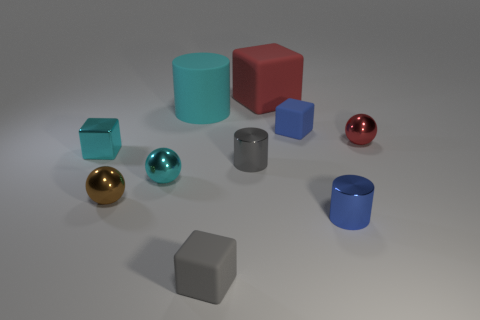What number of other objects are there of the same color as the big matte block?
Offer a terse response. 1. What is the shape of the brown shiny thing that is the same size as the gray matte cube?
Your response must be concise. Sphere. What number of large things are green metal balls or cyan metallic objects?
Give a very brief answer. 0. Is there a tiny matte block on the right side of the red object that is behind the ball that is to the right of the gray rubber block?
Ensure brevity in your answer.  Yes. Are there any metallic cylinders that have the same size as the red metal object?
Make the answer very short. Yes. What is the material of the gray cube that is the same size as the blue rubber block?
Offer a very short reply. Rubber. There is a gray rubber block; does it have the same size as the matte cube that is behind the big cylinder?
Make the answer very short. No. How many matte things are either cubes or small cyan spheres?
Ensure brevity in your answer.  3. What number of large cyan matte things have the same shape as the gray metal thing?
Offer a very short reply. 1. There is a sphere that is the same color as the metal block; what material is it?
Give a very brief answer. Metal. 